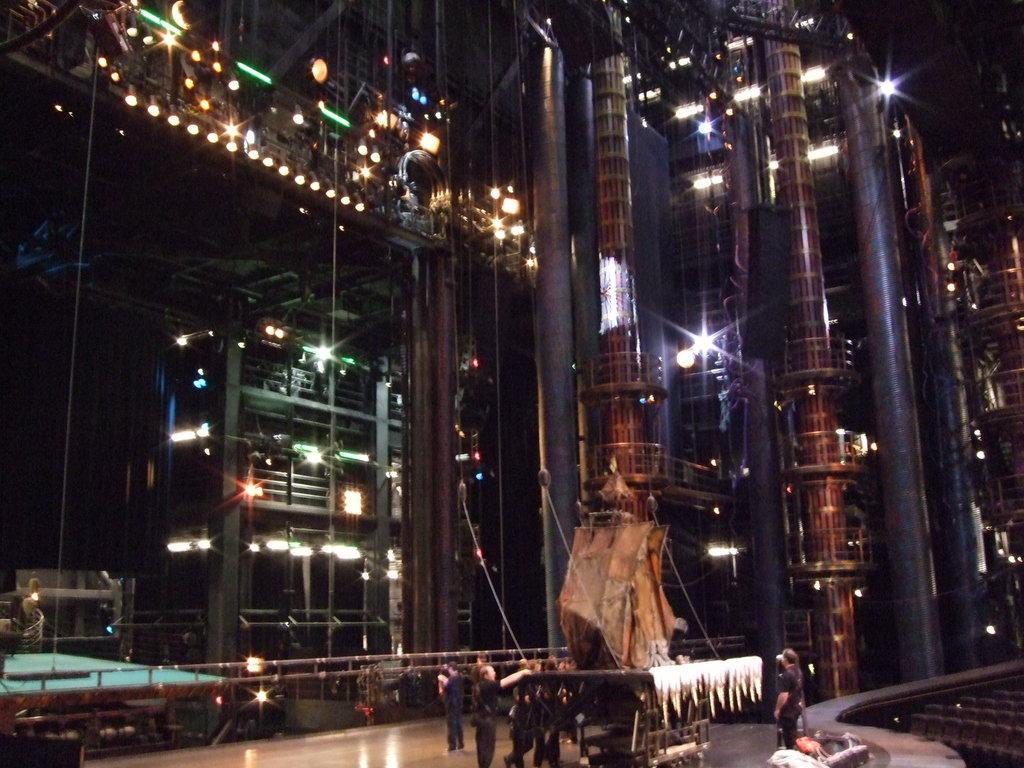What is happening in the center of the image? There are persons standing in the center of the image. What can be seen in the background of the image? There are buildings in the background of the image. How many dimes are visible on the ground in the image? There are no dimes visible on the ground in the image. What type of toy can be seen being played with by the persons in the image? There is no toy present in the image; the persons are simply standing. 